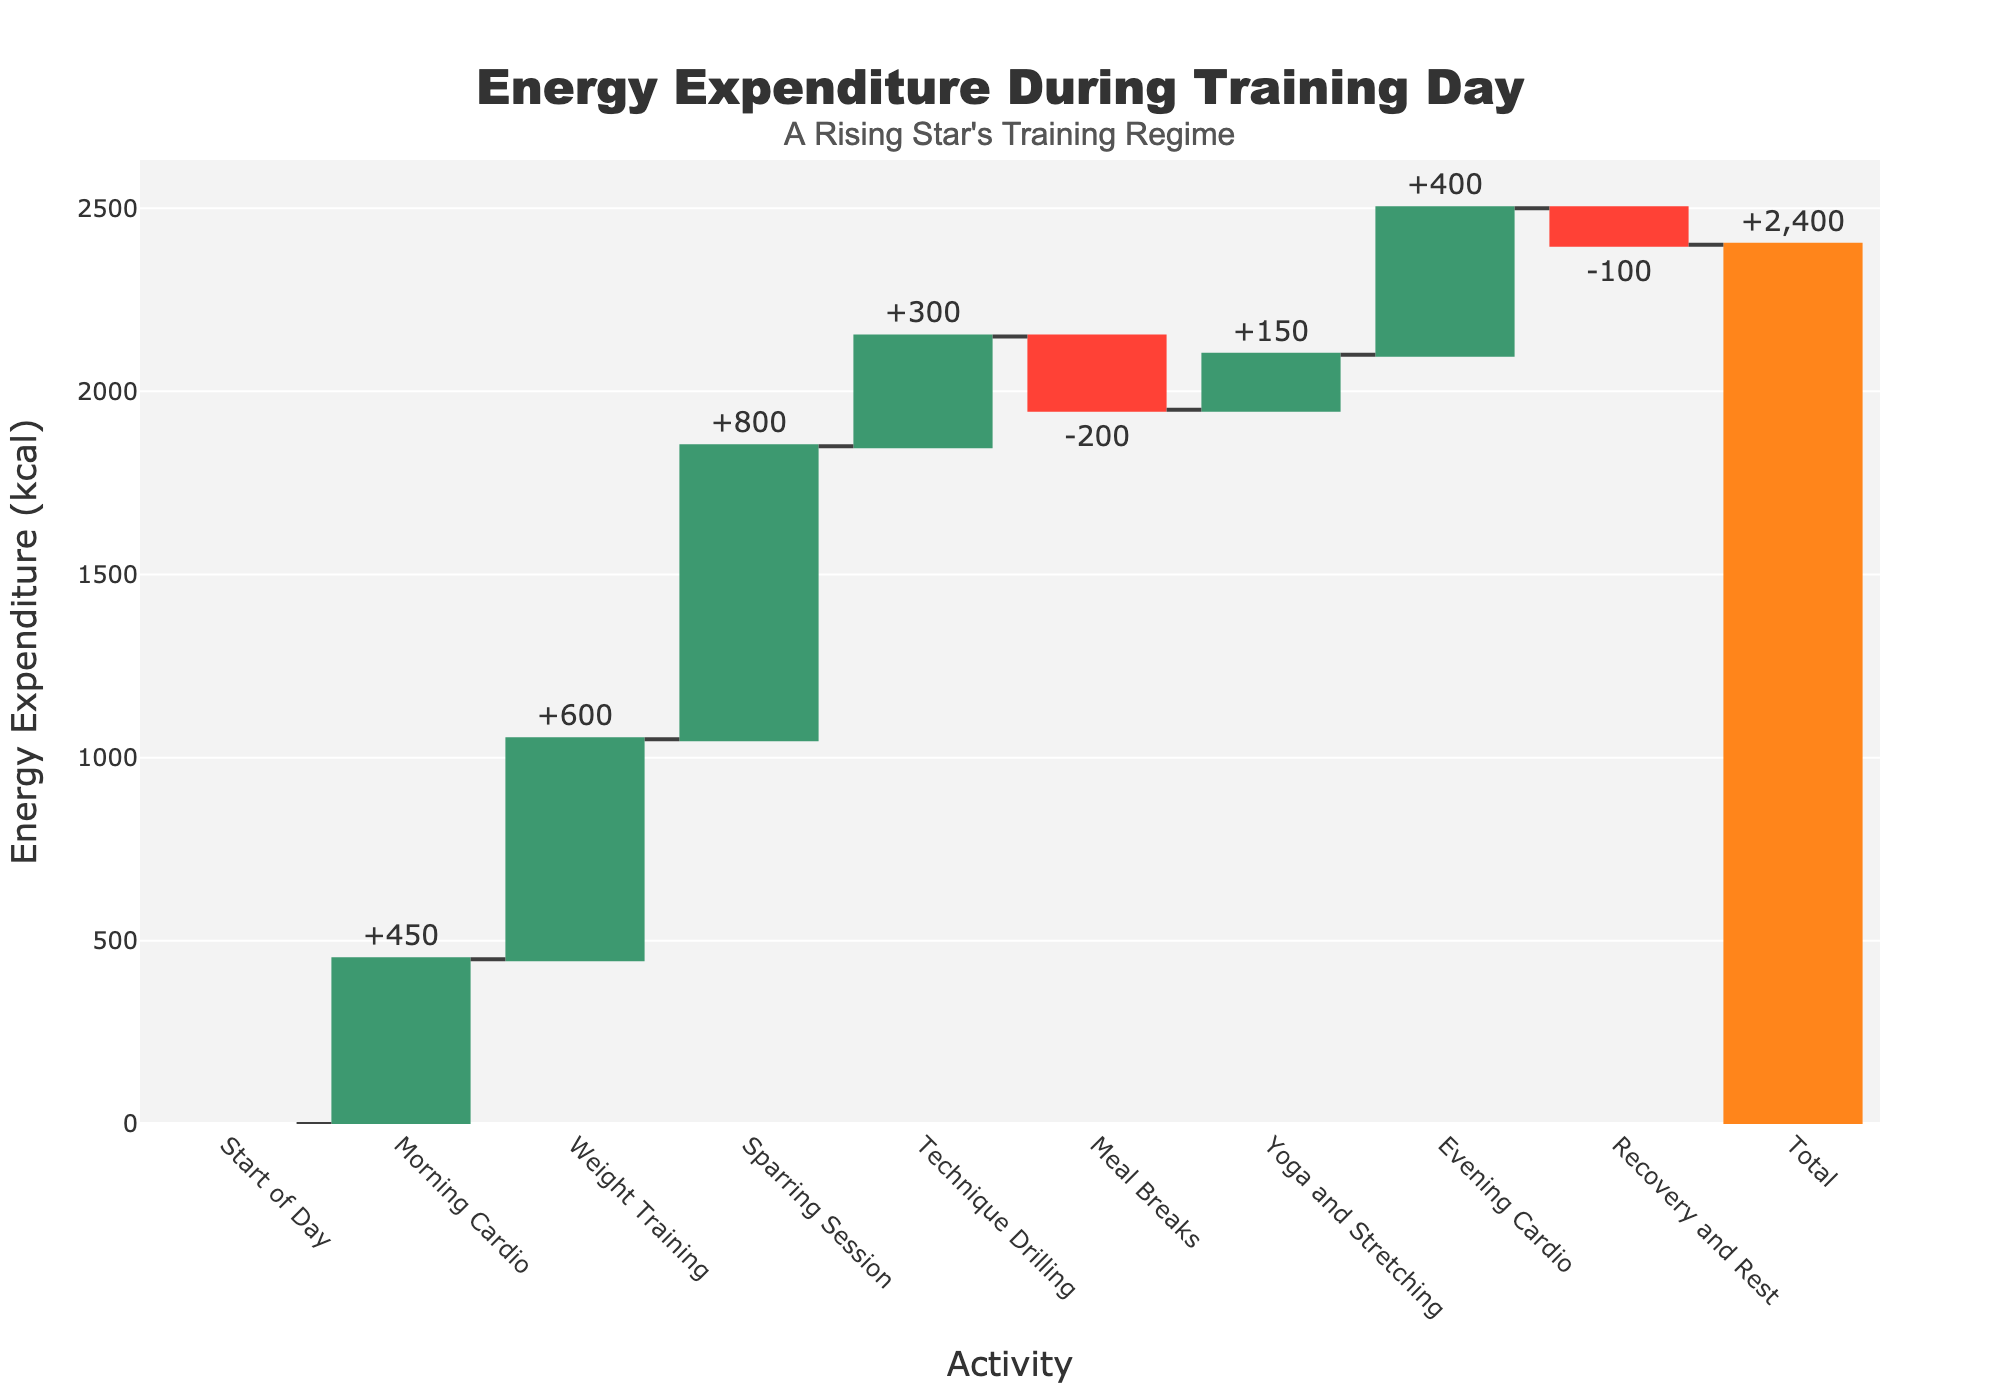What is the title of the chart? The title of the chart is usually positioned at the top of the figure. In this case, the title reads "Energy Expenditure During Training Day".
Answer: Energy Expenditure During Training Day How many activities are listed on the x-axis excluding the total? To determine the number of activities, count the entries listed along the x-axis, excluding the final "Total" entry. There are eight activities mentioned before "Total".
Answer: 8 What activity has the highest energy expenditure, and how much is it? To find the highest energy expenditure, look for the activity with the tallest bar pointing upwards. The Sparring Session has the highest energy expenditure of 800 kcal.
Answer: Sparring Session, 800 kcal What is the combined energy expenditure for both morning cardio sessions? Sum the energy expenditures of the Morning Cardio and Evening Cardio sessions. Morning Cardio is 450 kcal, and Evening Cardio is 400 kcal. Their combined expenditure is 450 + 400 = 850 kcal.
Answer: 850 kcal Which activities contribute negatively to the total energy expenditure, and what are their values? Look for the activities with bars pointing downwards. Meal Breaks (-200 kcal) and Recovery and Rest (-100 kcal) both contribute negatively.
Answer: Meal Breaks (-200 kcal), Recovery and Rest (-100 kcal) What is the net energy gain or loss from meals and recovery/rest sessions combined? Sum the values of Meal Breaks and Recovery and Rest to find the net effect. Meal Breaks: -200 kcal, Recovery and Rest: -100 kcal. Combined, it is -200 + (-100) = -300 kcal.
Answer: -300 kcal How does the weight training session compare in energy expenditure to the technique drilling session? Compare the heights and values of the bars for these two activities. Weight Training is 600 kcal, and Technique Drilling is 300 kcal. Weight Training has 600 - 300 = 300 kcal more expenditure than Technique Drilling.
Answer: Weight Training has 300 kcal more After which activity does the total energy expenditure first exceed 1000 kcal? Track the cumulative energy expenditure through the sequence of activities. The energy expenditure first exceeds 1000 kcal after the Weight Training session, where it reaches 450 (Morning Cardio) + 600 (Weight Training) = 1050 kcal.
Answer: After Weight Training What is the total energy expenditure at the end of the day? Refer to the ending bar labeled as "Total". The total energy expenditure at the end of the day is provided directly as 2400 kcal.
Answer: 2400 kcal 